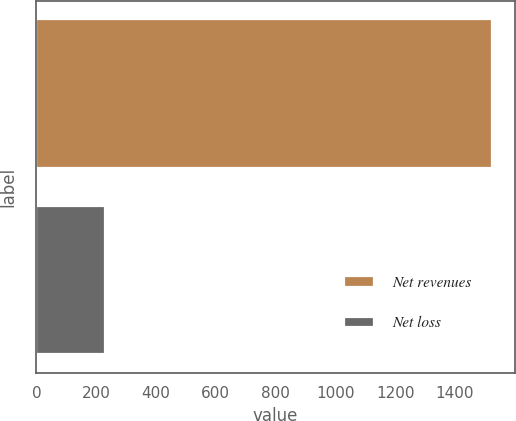Convert chart. <chart><loc_0><loc_0><loc_500><loc_500><bar_chart><fcel>Net revenues<fcel>Net loss<nl><fcel>1523<fcel>230<nl></chart> 